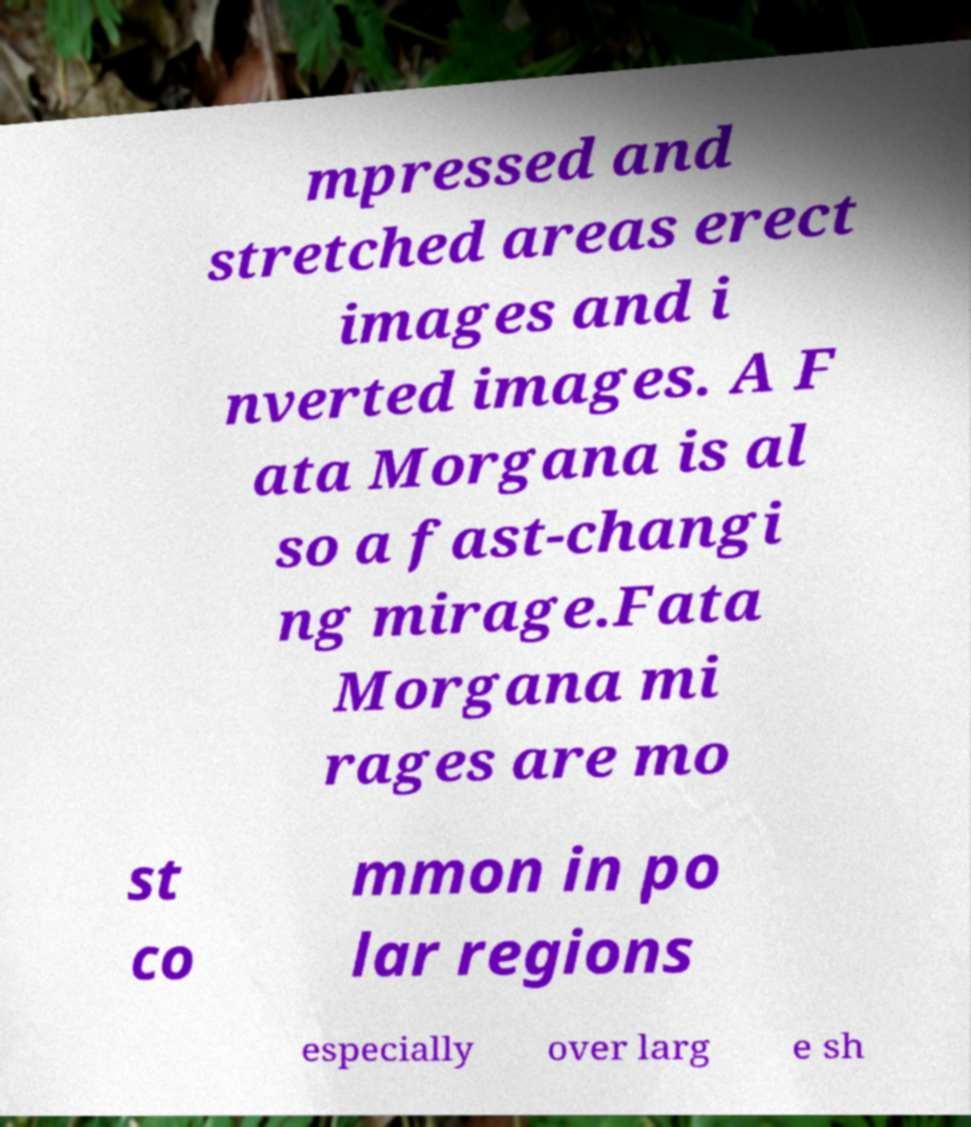Please identify and transcribe the text found in this image. mpressed and stretched areas erect images and i nverted images. A F ata Morgana is al so a fast-changi ng mirage.Fata Morgana mi rages are mo st co mmon in po lar regions especially over larg e sh 